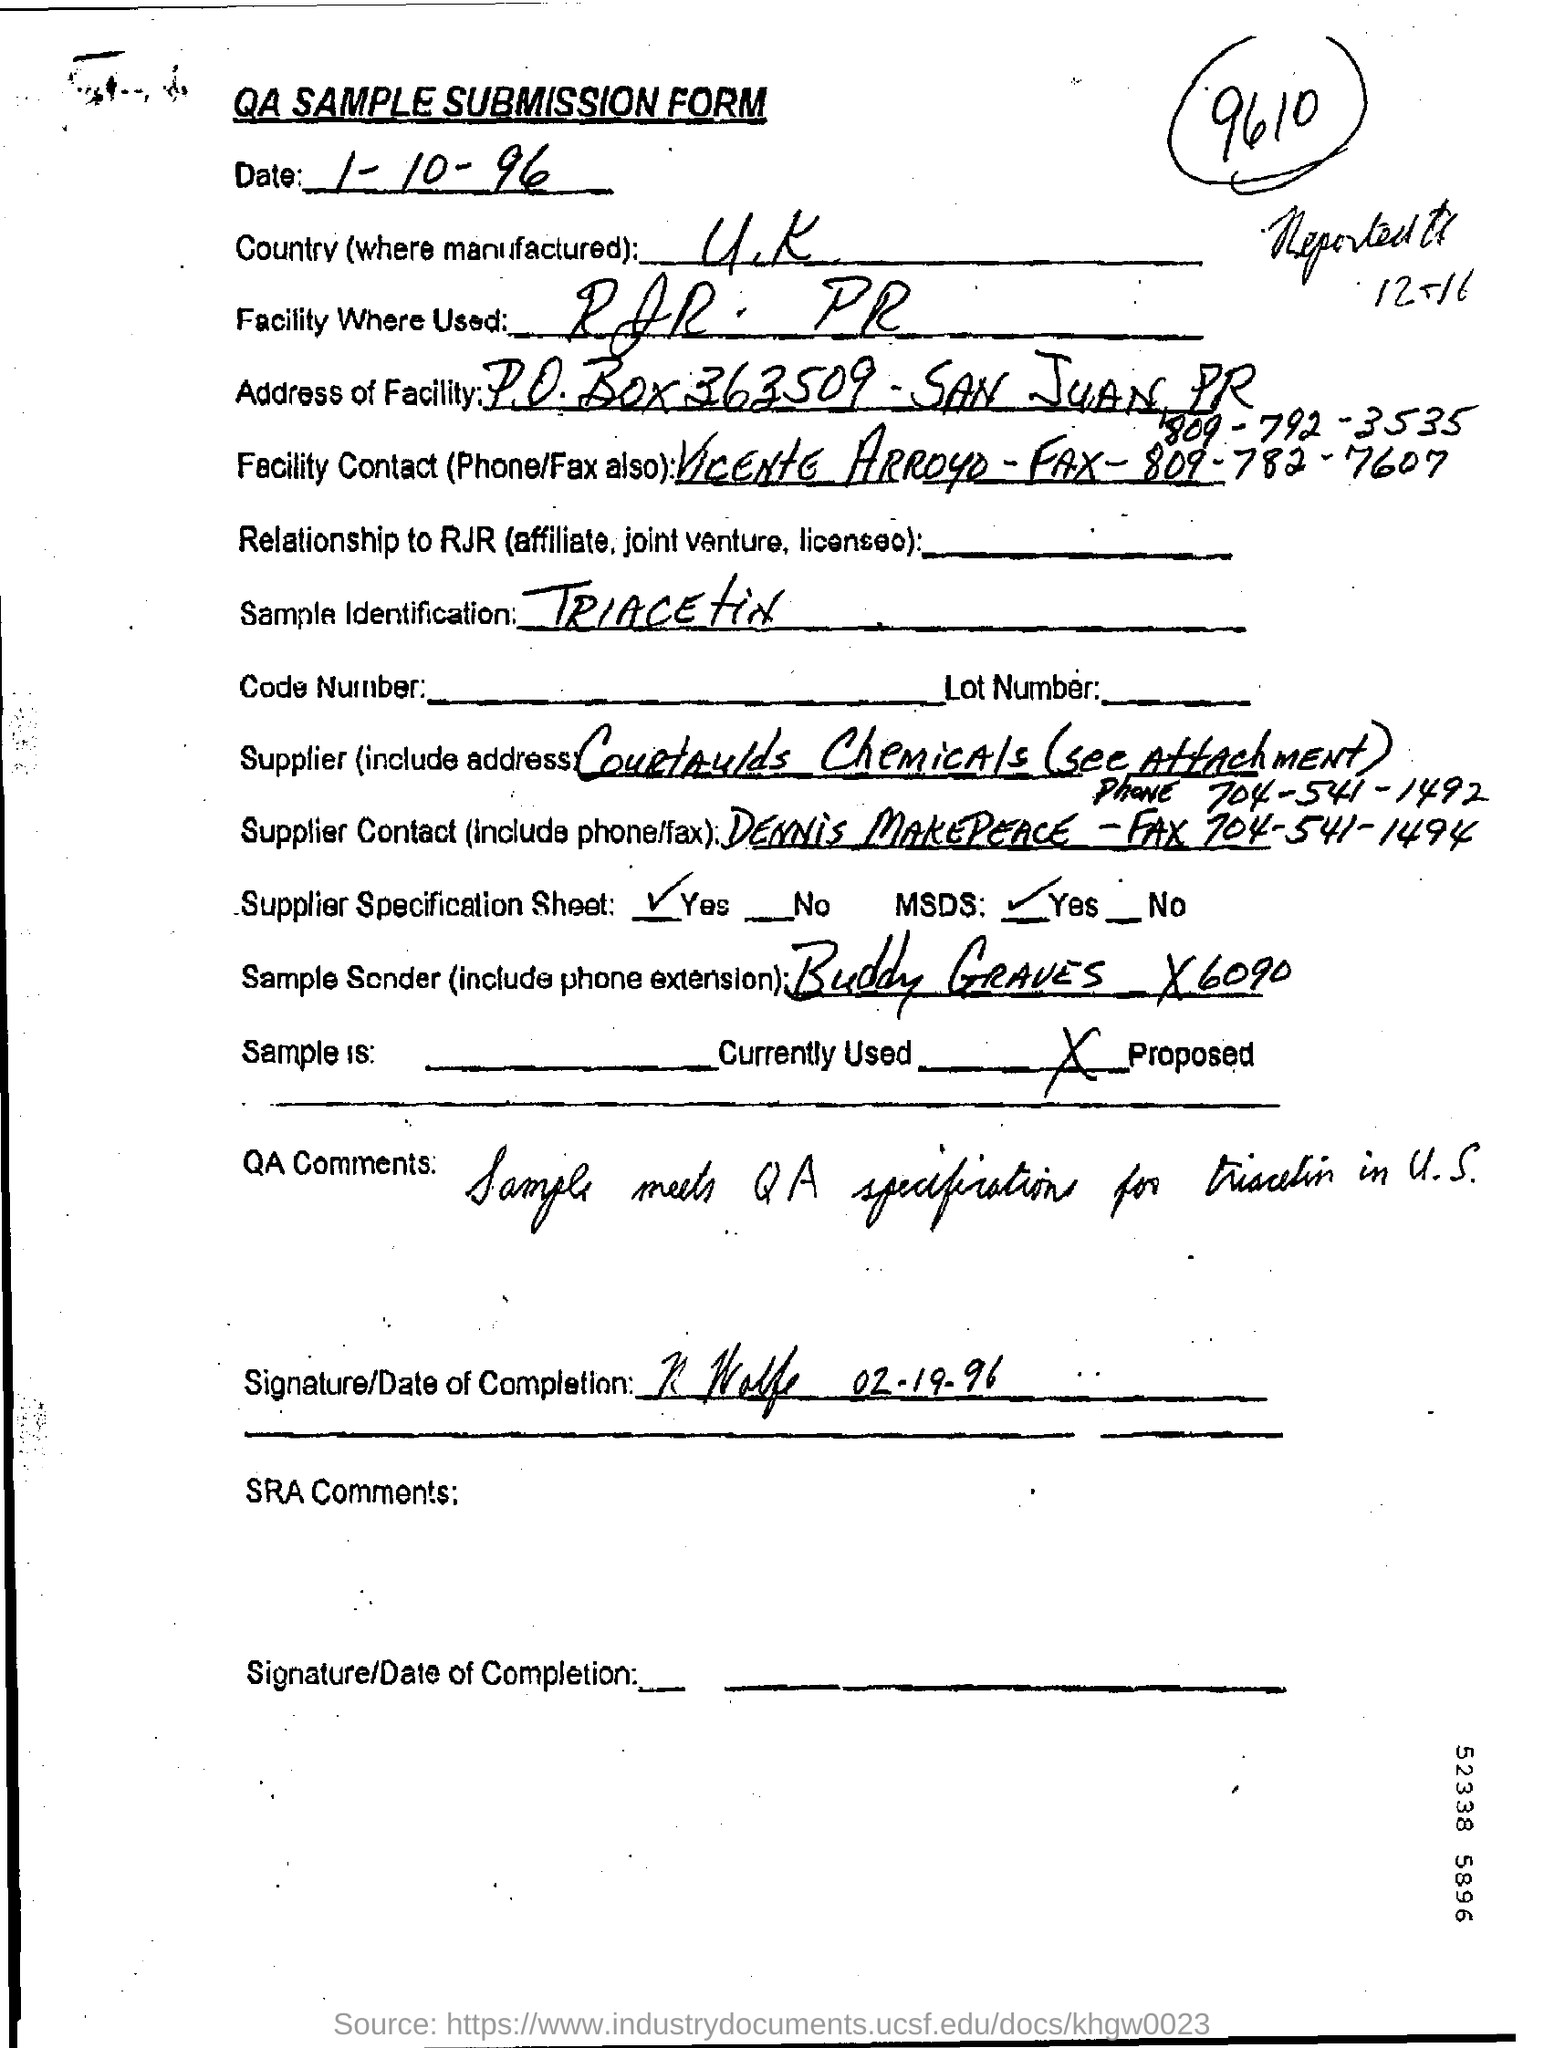Outline some significant characteristics in this image. The Supplier Contact is Dennis Makepeace. The sample sender is Buddy Graves. The product was manufactured in the United Kingdom. On October 1st, 1996, the date was. The sample is identified as "Triacetin. 